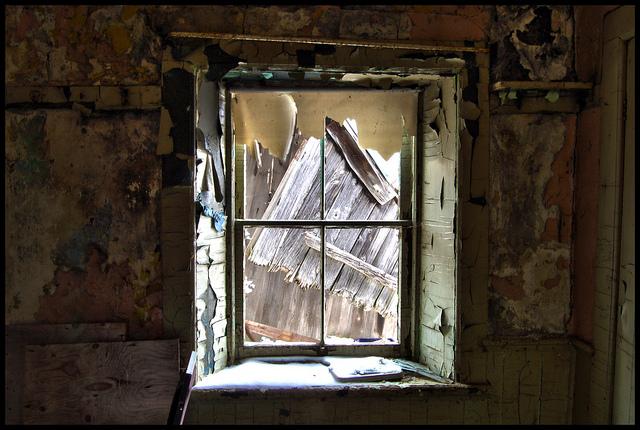Is the window broken?
Give a very brief answer. Yes. Is the windowsill made out of wood?
Write a very short answer. Yes. Do you look out for in the window?
Be succinct. Out. Is this room well kept?
Give a very brief answer. No. Is this a house?
Answer briefly. Yes. 